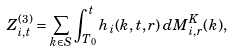Convert formula to latex. <formula><loc_0><loc_0><loc_500><loc_500>Z ^ { ( 3 ) } _ { i , t } = \sum _ { k \in S } \int _ { T _ { 0 } } ^ { t } h _ { i } ( k , t , r ) \, d M ^ { K } _ { i , r } ( k ) ,</formula> 